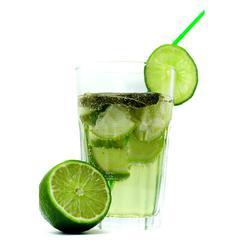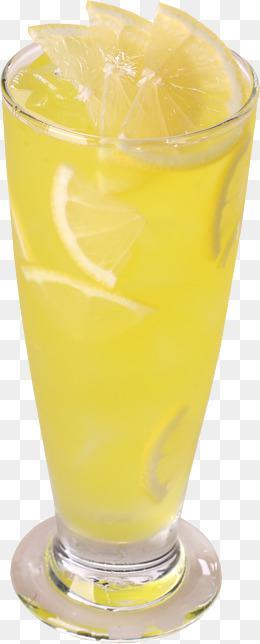The first image is the image on the left, the second image is the image on the right. Analyze the images presented: Is the assertion "One image includes a whole and half lemon and two green leaves by a yellow beverage in a glass with a flared top." valid? Answer yes or no. No. The first image is the image on the left, the second image is the image on the right. Evaluate the accuracy of this statement regarding the images: "There is a glass of lemonade with lemons next to it, there is 1/2 of a lemon and the lemon greens from the fruit are visible, the glass is smaller around on the bottom and tapers wider at the top". Is it true? Answer yes or no. No. 